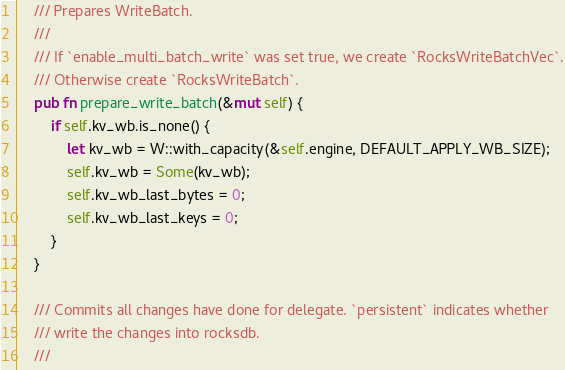Convert code to text. <code><loc_0><loc_0><loc_500><loc_500><_Rust_>
    /// Prepares WriteBatch.
    ///
    /// If `enable_multi_batch_write` was set true, we create `RocksWriteBatchVec`.
    /// Otherwise create `RocksWriteBatch`.
    pub fn prepare_write_batch(&mut self) {
        if self.kv_wb.is_none() {
            let kv_wb = W::with_capacity(&self.engine, DEFAULT_APPLY_WB_SIZE);
            self.kv_wb = Some(kv_wb);
            self.kv_wb_last_bytes = 0;
            self.kv_wb_last_keys = 0;
        }
    }

    /// Commits all changes have done for delegate. `persistent` indicates whether
    /// write the changes into rocksdb.
    ///</code> 